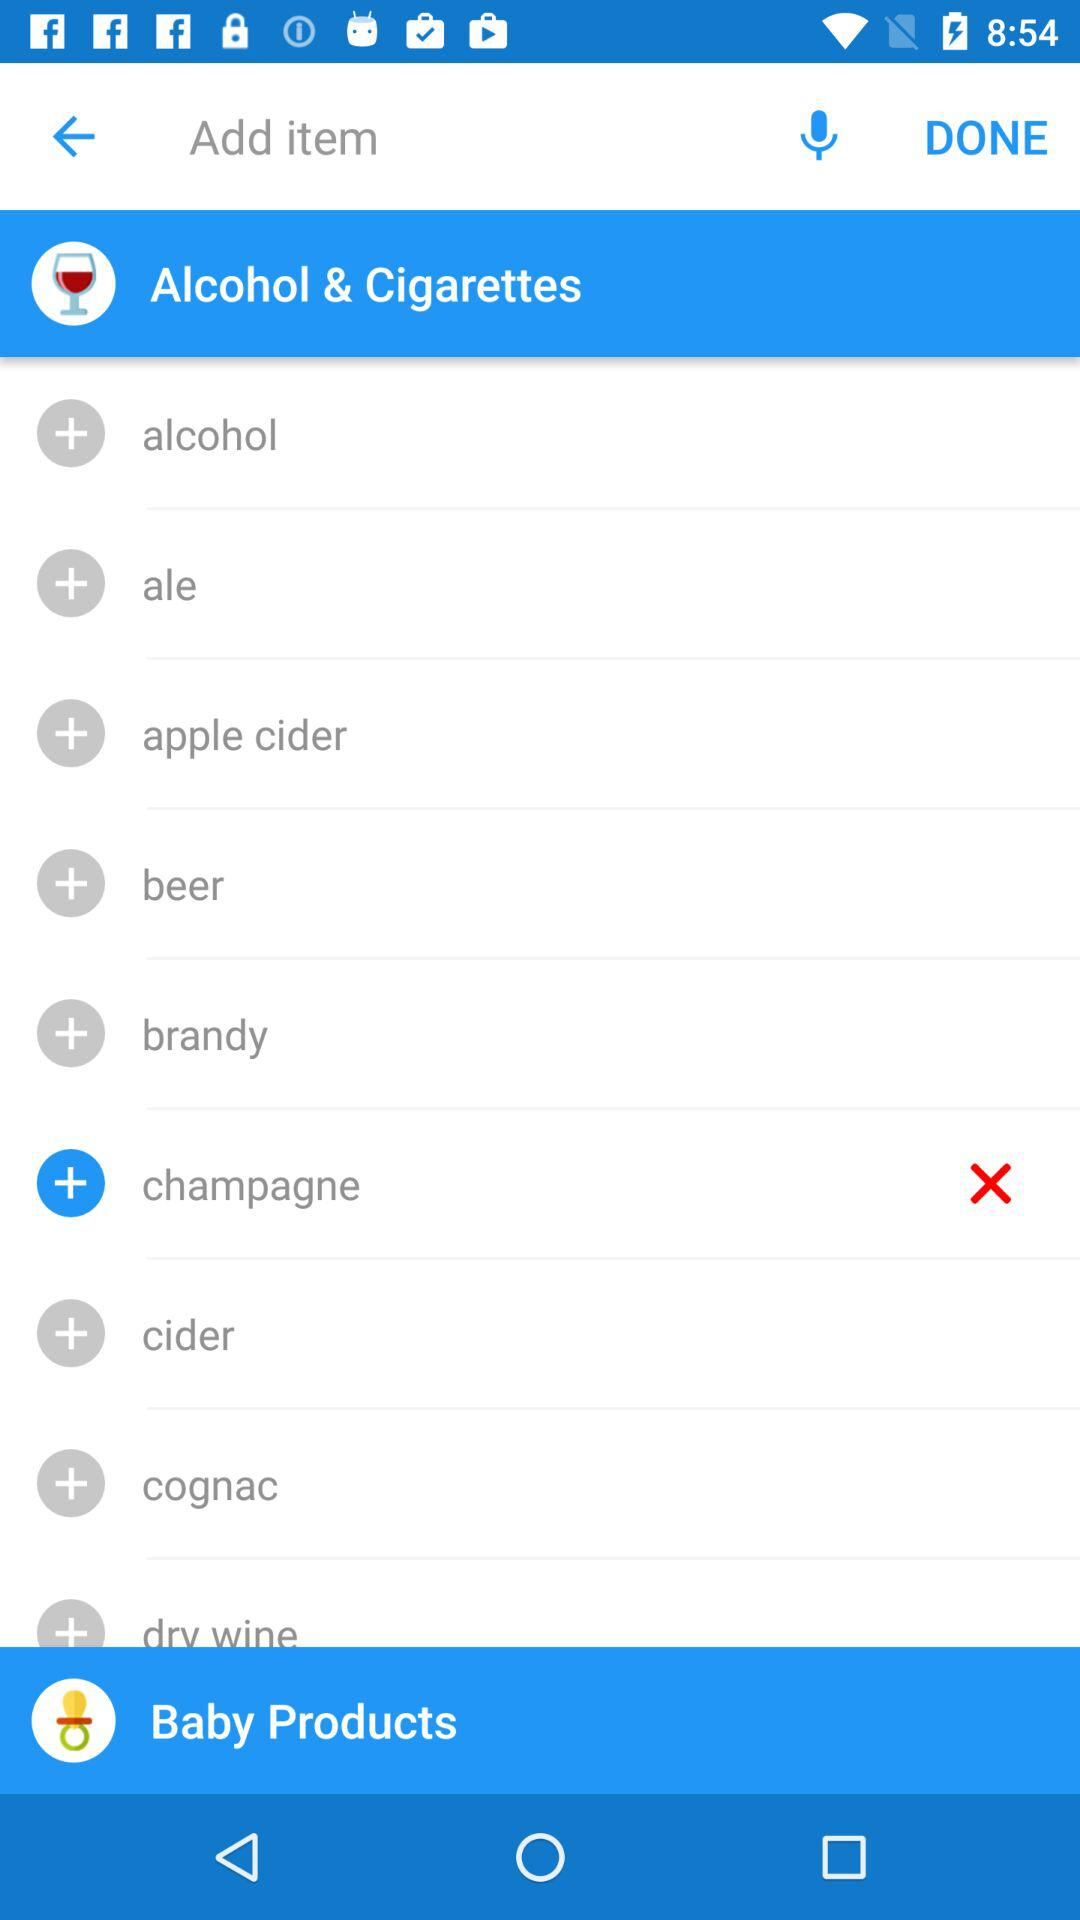Which option has been selected in "Alcohol & Cigarettes"? The selected option is "champagne". 